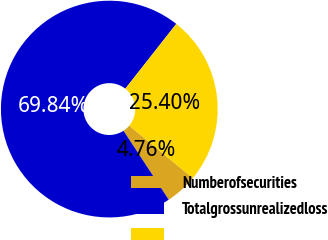<chart> <loc_0><loc_0><loc_500><loc_500><pie_chart><fcel>Numberofsecurities<fcel>Totalgrossunrealizedloss<fcel>Unnamed: 2<nl><fcel>4.76%<fcel>69.84%<fcel>25.4%<nl></chart> 